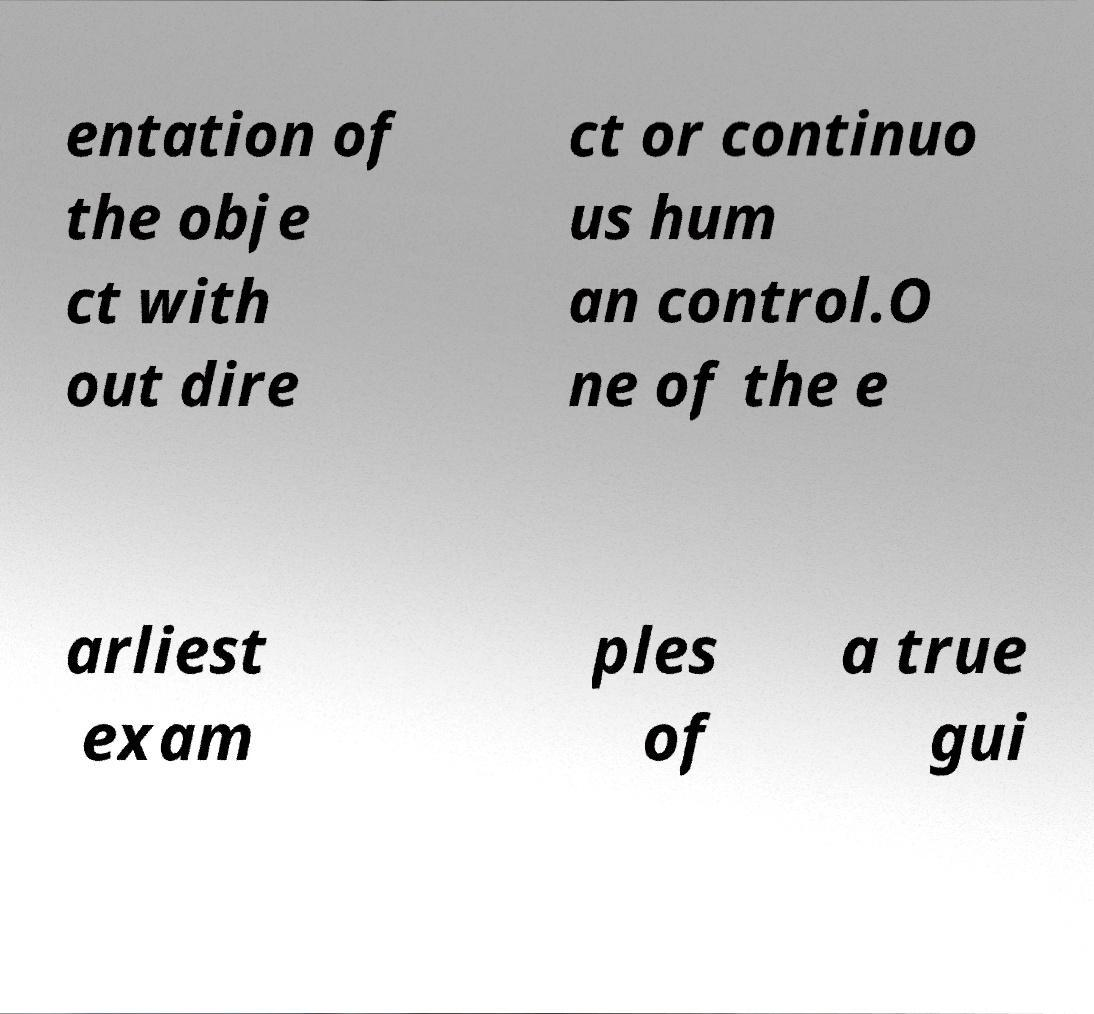Could you assist in decoding the text presented in this image and type it out clearly? entation of the obje ct with out dire ct or continuo us hum an control.O ne of the e arliest exam ples of a true gui 